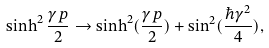Convert formula to latex. <formula><loc_0><loc_0><loc_500><loc_500>\sinh ^ { 2 } \frac { \gamma p } { 2 } \rightarrow \sinh ^ { 2 } ( \frac { \gamma p } { 2 } ) + \sin ^ { 2 } ( \frac { \hbar { \gamma } ^ { 2 } } { 4 } ) ,</formula> 